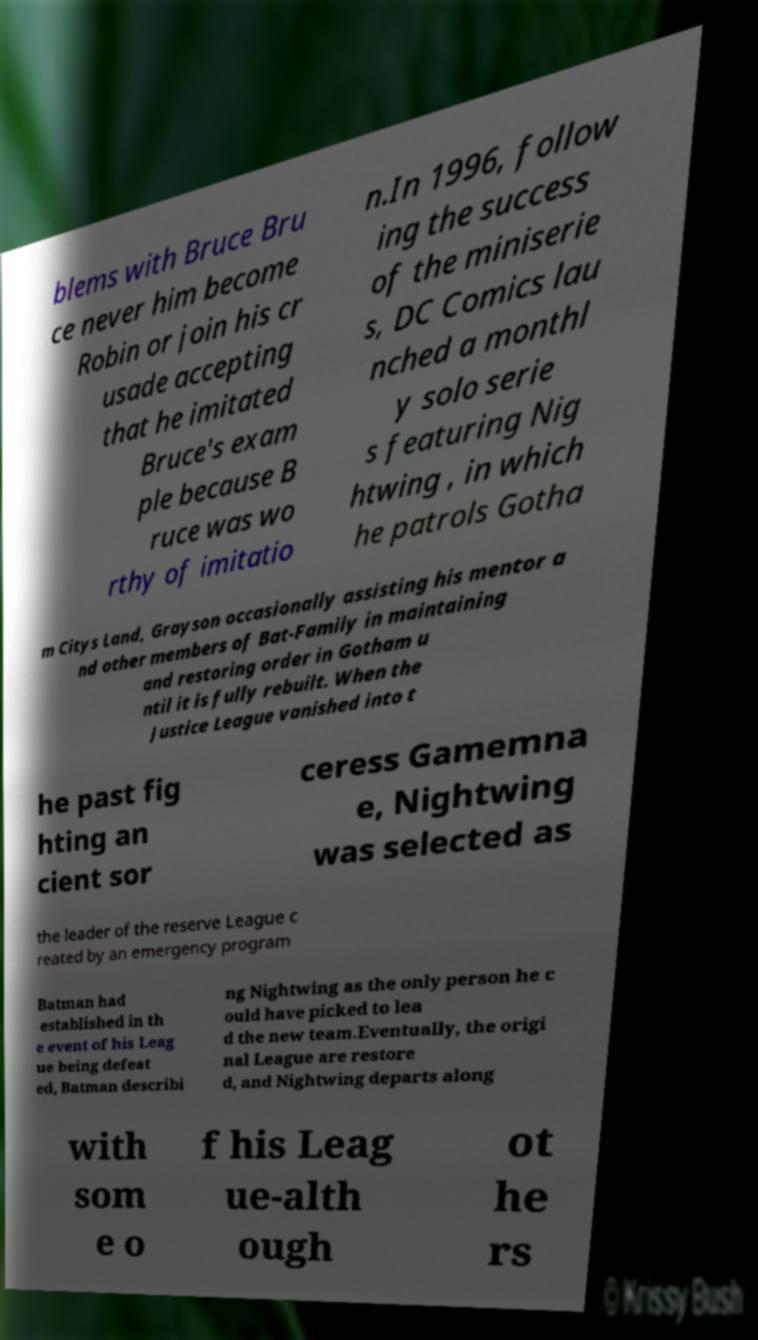Please read and relay the text visible in this image. What does it say? blems with Bruce Bru ce never him become Robin or join his cr usade accepting that he imitated Bruce's exam ple because B ruce was wo rthy of imitatio n.In 1996, follow ing the success of the miniserie s, DC Comics lau nched a monthl y solo serie s featuring Nig htwing , in which he patrols Gotha m Citys Land, Grayson occasionally assisting his mentor a nd other members of Bat-Family in maintaining and restoring order in Gotham u ntil it is fully rebuilt. When the Justice League vanished into t he past fig hting an cient sor ceress Gamemna e, Nightwing was selected as the leader of the reserve League c reated by an emergency program Batman had established in th e event of his Leag ue being defeat ed, Batman describi ng Nightwing as the only person he c ould have picked to lea d the new team.Eventually, the origi nal League are restore d, and Nightwing departs along with som e o f his Leag ue-alth ough ot he rs 